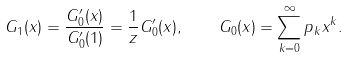Convert formula to latex. <formula><loc_0><loc_0><loc_500><loc_500>G _ { 1 } ( x ) = \frac { G ^ { \prime } _ { 0 } ( x ) } { G ^ { \prime } _ { 0 } ( 1 ) } = \frac { 1 } { z } G ^ { \prime } _ { 0 } ( x ) , \quad G _ { 0 } ( x ) = \sum _ { k = 0 } ^ { \infty } p _ { k } x ^ { k } .</formula> 